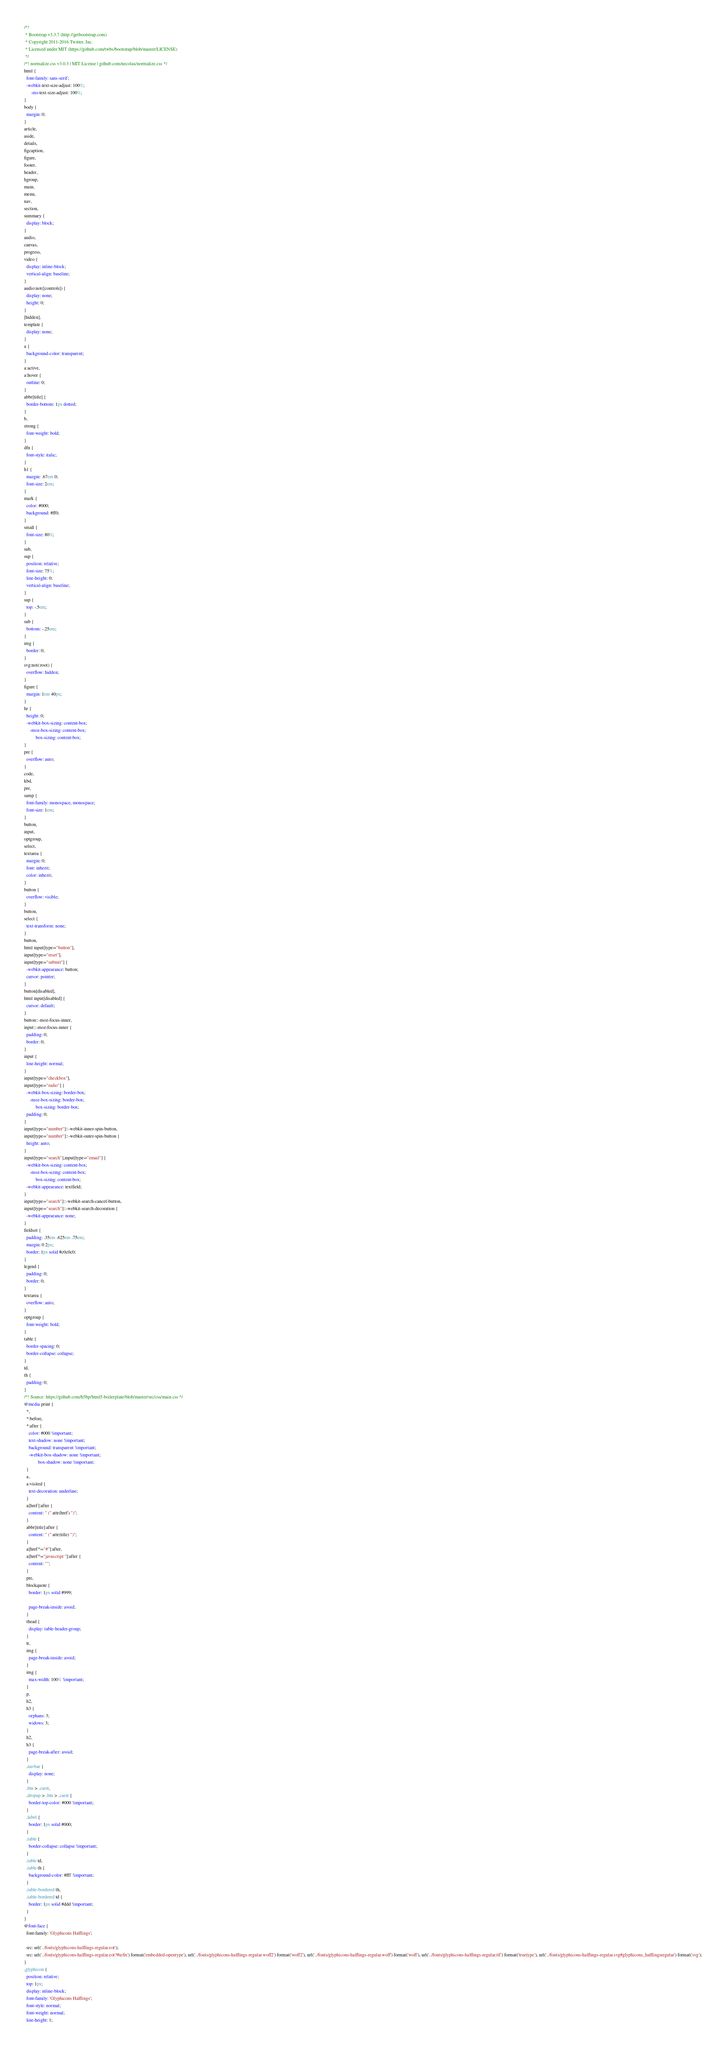<code> <loc_0><loc_0><loc_500><loc_500><_CSS_>/*!
 * Bootstrap v3.3.7 (http://getbootstrap.com)
 * Copyright 2011-2016 Twitter, Inc.
 * Licensed under MIT (https://github.com/twbs/bootstrap/blob/master/LICENSE)
 */
/*! normalize.css v3.0.3 | MIT License | github.com/necolas/normalize.css */
html {
  font-family: sans-serif;
  -webkit-text-size-adjust: 100%;
      -ms-text-size-adjust: 100%;
}
body {
  margin: 0;
}
article,
aside,
details,
figcaption,
figure,
footer,
header,
hgroup,
main,
menu,
nav,
section,
summary {
  display: block;
}
audio,
canvas,
progress,
video {
  display: inline-block;
  vertical-align: baseline;
}
audio:not([controls]) {
  display: none;
  height: 0;
}
[hidden],
template {
  display: none;
}
a {
  background-color: transparent;
}
a:active,
a:hover {
  outline: 0;
}
abbr[title] {
  border-bottom: 1px dotted;
}
b,
strong {
  font-weight: bold;
}
dfn {
  font-style: italic;
}
h1 {
  margin: .67em 0;
  font-size: 2em;
}
mark {
  color: #000;
  background: #ff0;
}
small {
  font-size: 80%;
}
sub,
sup {
  position: relative;
  font-size: 75%;
  line-height: 0;
  vertical-align: baseline;
}
sup {
  top: -.5em;
}
sub {
  bottom: -.25em;
}
img {
  border: 0;
}
svg:not(:root) {
  overflow: hidden;
}
figure {
  margin: 1em 40px;
}
hr {
  height: 0;
  -webkit-box-sizing: content-box;
     -moz-box-sizing: content-box;
          box-sizing: content-box;
}
pre {
  overflow: auto;
}
code,
kbd,
pre,
samp {
  font-family: monospace, monospace;
  font-size: 1em;
}
button,
input,
optgroup,
select,
textarea {
  margin: 0;
  font: inherit;
  color: inherit;
}
button {
  overflow: visible;
}
button,
select {
  text-transform: none;
}
button,
html input[type="button"],
input[type="reset"],
input[type="submit"] {
  -webkit-appearance: button;
  cursor: pointer;
}
button[disabled],
html input[disabled] {
  cursor: default;
}
button::-moz-focus-inner,
input::-moz-focus-inner {
  padding: 0;
  border: 0;
}
input {
  line-height: normal;
}
input[type="checkbox"],
input[type="radio"] {
  -webkit-box-sizing: border-box;
     -moz-box-sizing: border-box;
          box-sizing: border-box;
  padding: 0;
}
input[type="number"]::-webkit-inner-spin-button,
input[type="number"]::-webkit-outer-spin-button {
  height: auto;
}
input[type="search"],input[type="email"] {
  -webkit-box-sizing: content-box;
     -moz-box-sizing: content-box;
          box-sizing: content-box;
  -webkit-appearance: textfield;
}
input[type="search"]::-webkit-search-cancel-button,
input[type="search"]::-webkit-search-decoration {
  -webkit-appearance: none;
}
fieldset {
  padding: .35em .625em .75em;
  margin: 0 2px;
  border: 1px solid #c0c0c0;
}
legend {
  padding: 0;
  border: 0;
}
textarea {
  overflow: auto;
}
optgroup {
  font-weight: bold;
}
table {
  border-spacing: 0;
  border-collapse: collapse;
}
td,
th {
  padding: 0;
}
/*! Source: https://github.com/h5bp/html5-boilerplate/blob/master/src/css/main.css */
@media print {
  *,
  *:before,
  *:after {
    color: #000 !important;
    text-shadow: none !important;
    background: transparent !important;
    -webkit-box-shadow: none !important;
            box-shadow: none !important;
  }
  a,
  a:visited {
    text-decoration: underline;
  }
  a[href]:after {
    content: " (" attr(href) ")";
  }
  abbr[title]:after {
    content: " (" attr(title) ")";
  }
  a[href^="#"]:after,
  a[href^="javascript:"]:after {
    content: "";
  }
  pre,
  blockquote {
    border: 1px solid #999;

    page-break-inside: avoid;
  }
  thead {
    display: table-header-group;
  }
  tr,
  img {
    page-break-inside: avoid;
  }
  img {
    max-width: 100% !important;
  }
  p,
  h2,
  h3 {
    orphans: 3;
    widows: 3;
  }
  h2,
  h3 {
    page-break-after: avoid;
  }
  .navbar {
    display: none;
  }
  .btn > .caret,
  .dropup > .btn > .caret {
    border-top-color: #000 !important;
  }
  .label {
    border: 1px solid #000;
  }
  .table {
    border-collapse: collapse !important;
  }
  .table td,
  .table th {
    background-color: #fff !important;
  }
  .table-bordered th,
  .table-bordered td {
    border: 1px solid #ddd !important;
  }
}
@font-face {
  font-family: 'Glyphicons Halflings';

  src: url('../fonts/glyphicons-halflings-regular.eot');
  src: url('../fonts/glyphicons-halflings-regular.eot?#iefix') format('embedded-opentype'), url('../fonts/glyphicons-halflings-regular.woff2') format('woff2'), url('../fonts/glyphicons-halflings-regular.woff') format('woff'), url('../fonts/glyphicons-halflings-regular.ttf') format('truetype'), url('../fonts/glyphicons-halflings-regular.svg#glyphicons_halflingsregular') format('svg');
}
.glyphicon {
  position: relative;
  top: 1px;
  display: inline-block;
  font-family: 'Glyphicons Halflings';
  font-style: normal;
  font-weight: normal;
  line-height: 1;
</code> 